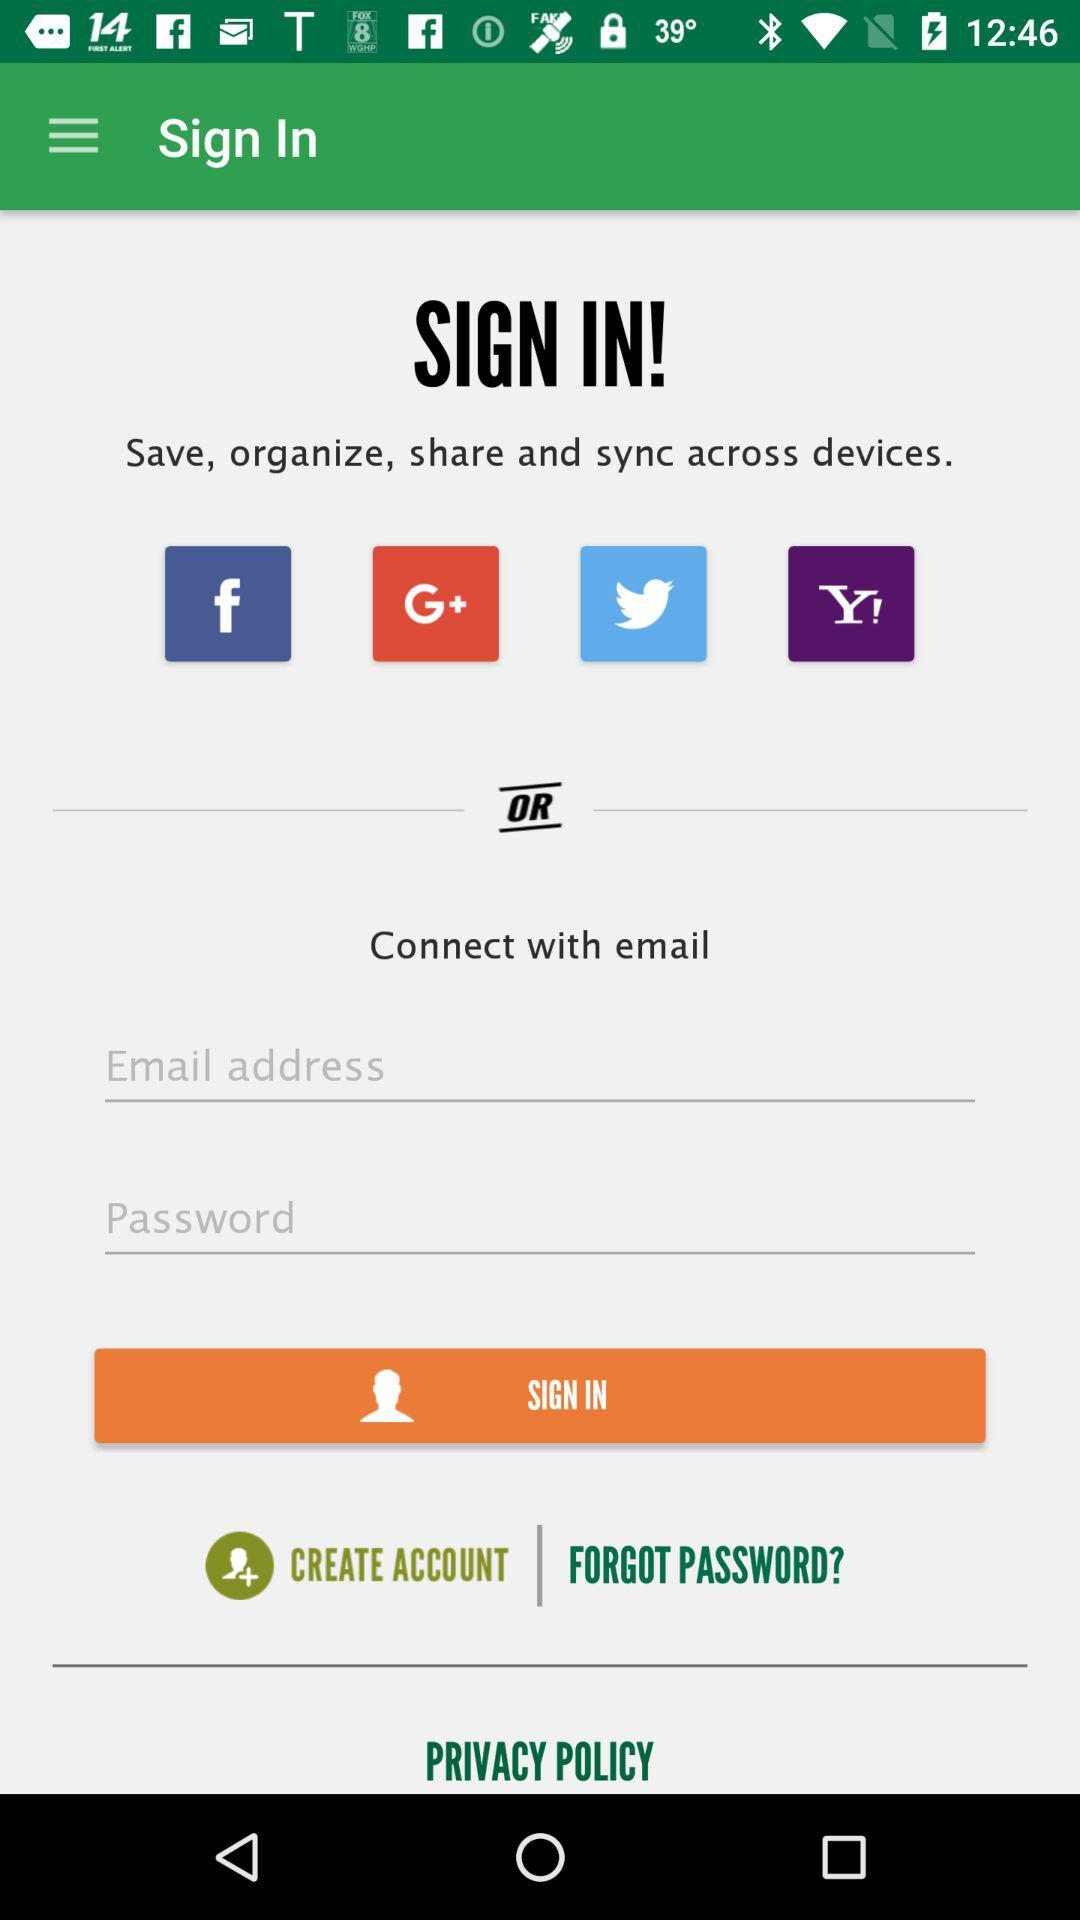How many social media login options are there?
Answer the question using a single word or phrase. 4 